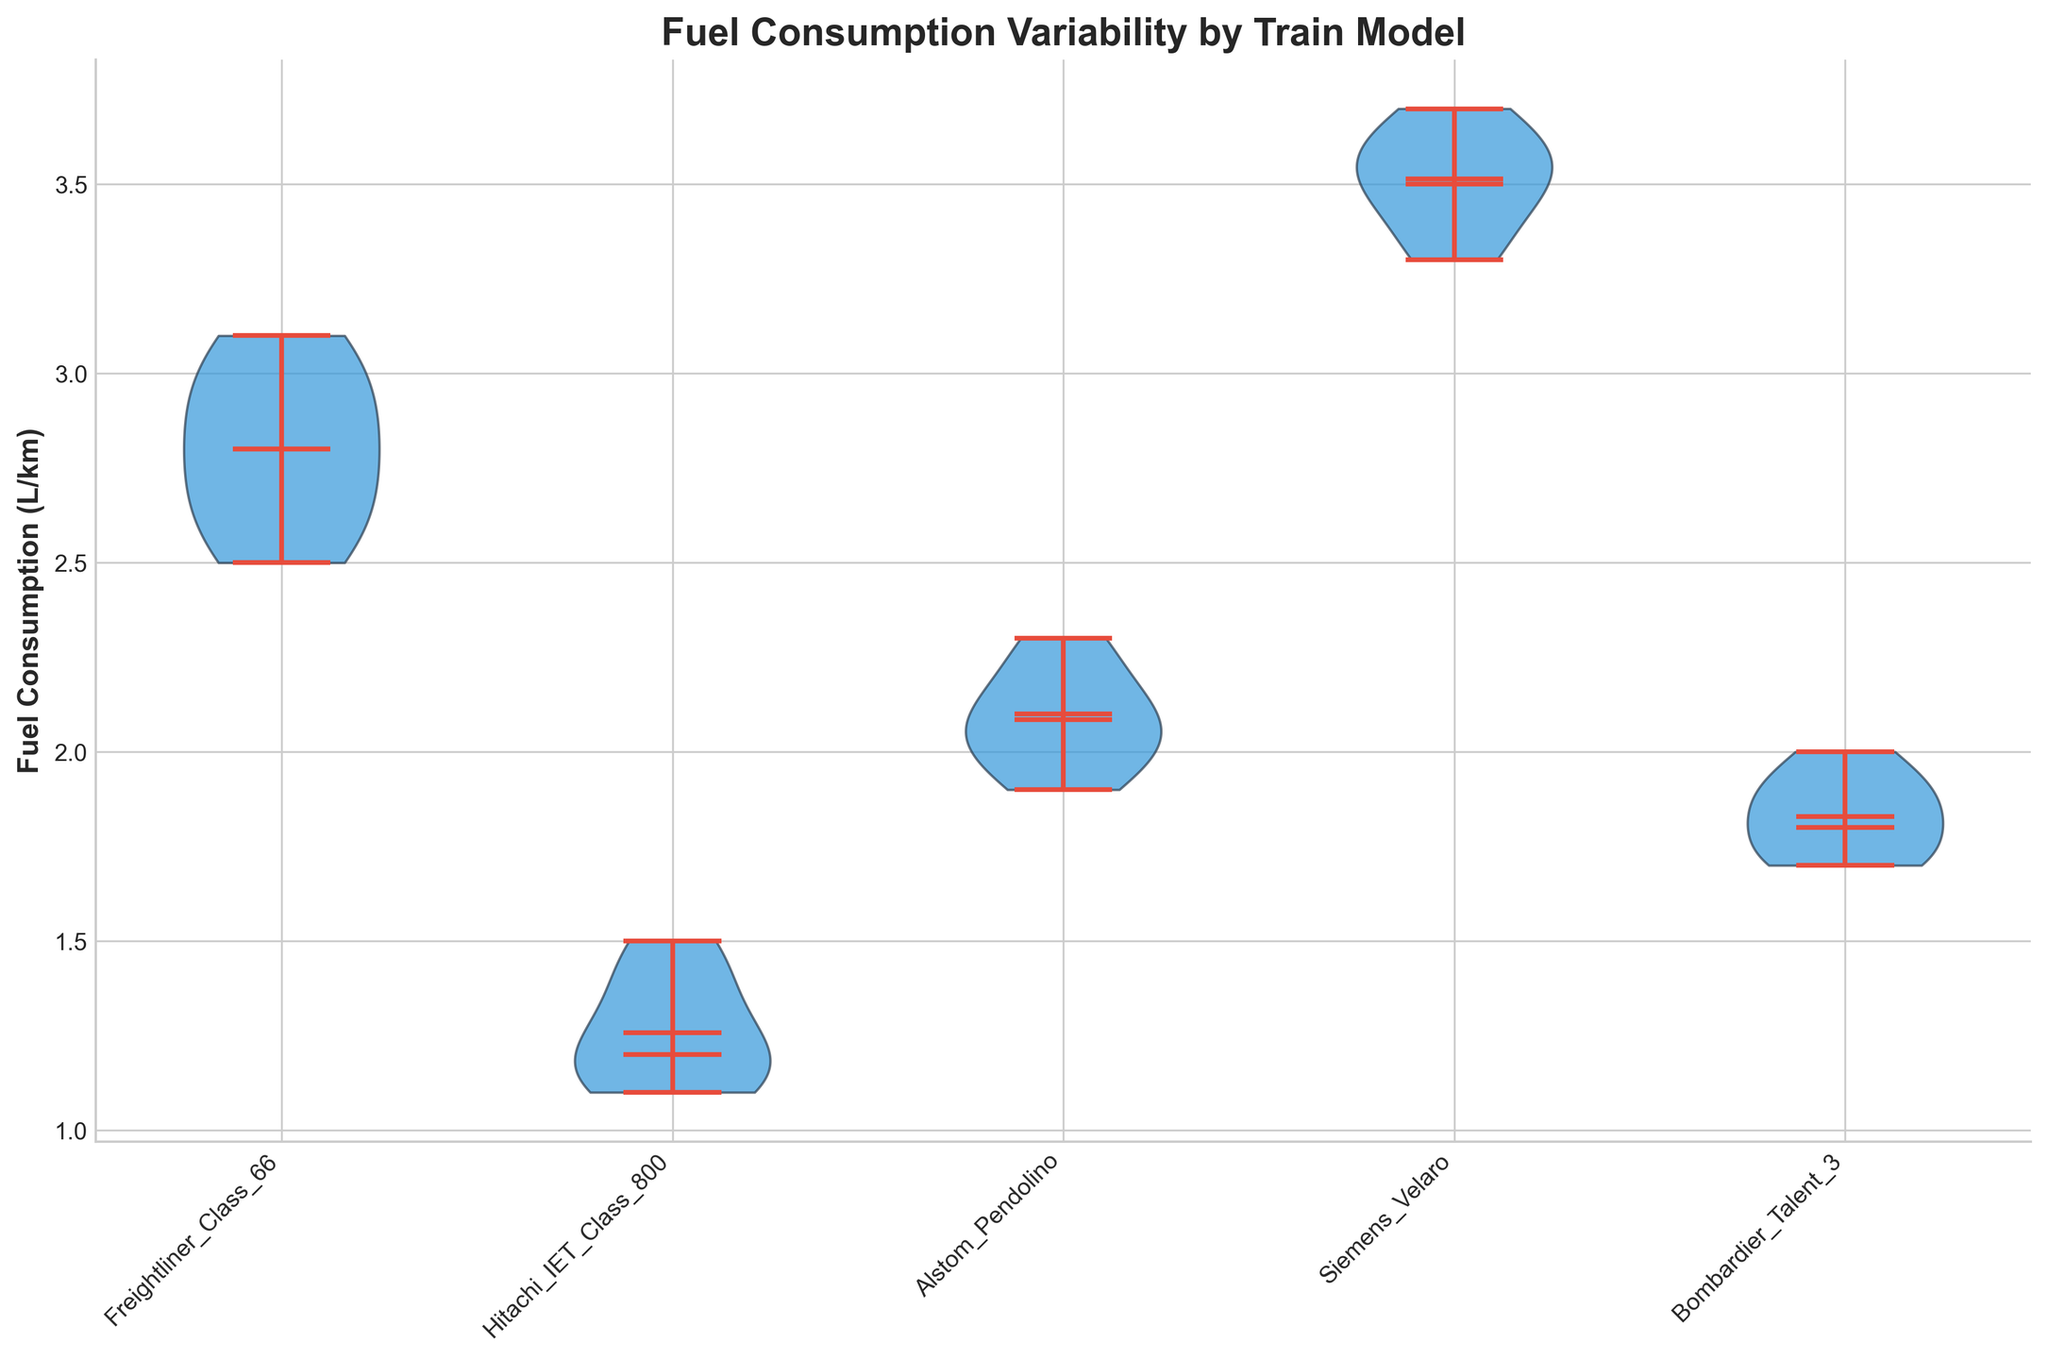What is the title of the plot? The title of the plot is usually displayed at the top and summarizes what the plot is about. In this case, it states "Fuel Consumption Variability by Train Model".
Answer: Fuel Consumption Variability by Train Model What are the train models compared in the plot? The x-axis ticks label each train model compared in the plot: Freightliner_Class_66, Hitachi_IET_Class_800, Alstom_Pendolino, Siemens_Velaro, and Bombardier_Talent_3. They are listed individually.
Answer: Freightliner_Class_66, Hitachi_IET_Class_800, Alstom_Pendolino, Siemens_Velaro, Bombardier_Talent_3 Which train model has the lowest median fuel consumption? The median fuel consumption is shown with a horizontal line within each violin plot. By visually inspecting these lines, Hitachi_IET_Class_800 has the lowest median fuel consumption.
Answer: Hitachi_IET_Class_800 Which train model has the highest range in fuel consumption? The range of fuel consumption is indicated by the ends of the violin plot. The Siemens_Velaro model has the most extended range from minimum to maximum values.
Answer: Siemens_Velaro How does the mean fuel consumption of Freightliner_Class_66 compare with Alstom_Pendolino? The mean fuel consumption is marked with a dot within the violin plots. By comparing these dots, Freightliner_Class_66 has a higher mean fuel consumption than Alstom_Pendolino.
Answer: Higher What is the approximate mean fuel consumption for Siemens_Velaro? The mean for Siemens_Velaro is shown as a small dot in the violin plot. It is positioned around 3.5 L/km.
Answer: Approximately 3.5 L/km Which train model has the smallest variability in fuel consumption? Variability in fuel consumption can be assessed by the width and spread of the violin plots. Hitachi_IET_Class_800 has the narrowest violin plot, indicating the smallest variability.
Answer: Hitachi_IET_Class_800 Is the mean fuel consumption of Bombardier_Talent_3 greater than that of Hitachi_IET_Class_800? Compare the positions of the mean markers (small dots) in the violin plots for both models. Yes, the mean fuel consumption of Bombardier_Talent_3 (around 1.8) is greater than that of Hitachi_IET_Class_800 (around 1.3).
Answer: Yes Does any train model have a median that exactly aligns with its mean? Look at the position of the median line relative to the mean dot within each violin plot. None of the train models have their median exactly matching their mean.
Answer: No 